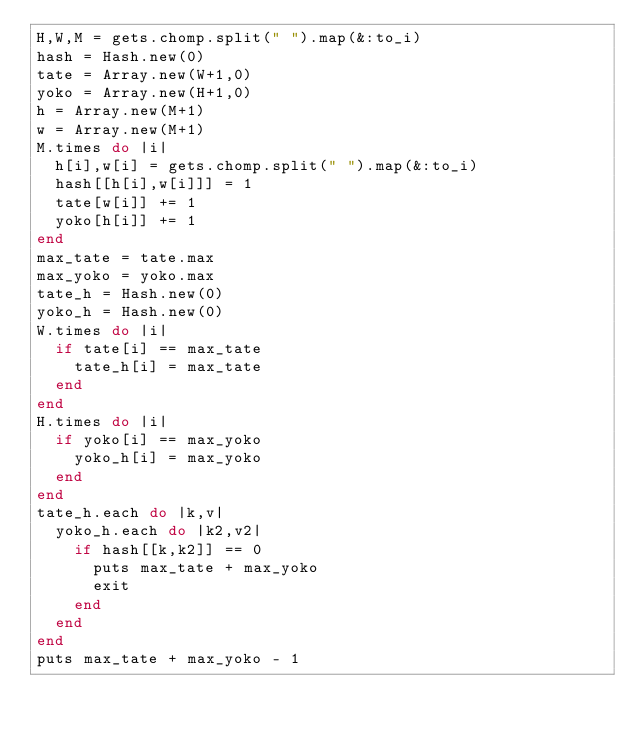<code> <loc_0><loc_0><loc_500><loc_500><_Ruby_>H,W,M = gets.chomp.split(" ").map(&:to_i)
hash = Hash.new(0)
tate = Array.new(W+1,0)
yoko = Array.new(H+1,0)
h = Array.new(M+1)
w = Array.new(M+1)
M.times do |i|
  h[i],w[i] = gets.chomp.split(" ").map(&:to_i)
  hash[[h[i],w[i]]] = 1
  tate[w[i]] += 1
  yoko[h[i]] += 1
end
max_tate = tate.max
max_yoko = yoko.max
tate_h = Hash.new(0)
yoko_h = Hash.new(0)
W.times do |i|
  if tate[i] == max_tate
    tate_h[i] = max_tate
  end
end
H.times do |i|
  if yoko[i] == max_yoko
    yoko_h[i] = max_yoko
  end
end
tate_h.each do |k,v|
  yoko_h.each do |k2,v2|
    if hash[[k,k2]] == 0
      puts max_tate + max_yoko
      exit
    end
  end
end
puts max_tate + max_yoko - 1</code> 